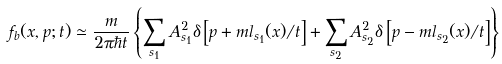<formula> <loc_0><loc_0><loc_500><loc_500>f _ { b } ( x , p ; t ) \simeq \frac { m } { 2 \pi \hbar { t } } \left \{ \sum _ { s _ { 1 } } A _ { s _ { 1 } } ^ { 2 } \delta \left [ p + m l _ { s _ { 1 } } ( x ) / t \right ] + \sum _ { s _ { 2 } } A _ { s _ { 2 } } ^ { 2 } \delta \left [ p - m l _ { s _ { 2 } } ( x ) / t \right ] \right \}</formula> 